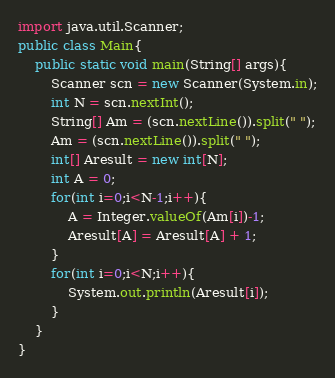Convert code to text. <code><loc_0><loc_0><loc_500><loc_500><_Java_>import java.util.Scanner;
public class Main{
    public static void main(String[] args){
        Scanner scn = new Scanner(System.in);
        int N = scn.nextInt();
        String[] Am = (scn.nextLine()).split(" ");
        Am = (scn.nextLine()).split(" ");
        int[] Aresult = new int[N];
        int A = 0;
        for(int i=0;i<N-1;i++){
            A = Integer.valueOf(Am[i])-1;
            Aresult[A] = Aresult[A] + 1;
        }
        for(int i=0;i<N;i++){
            System.out.println(Aresult[i]);
        }
    }
}</code> 